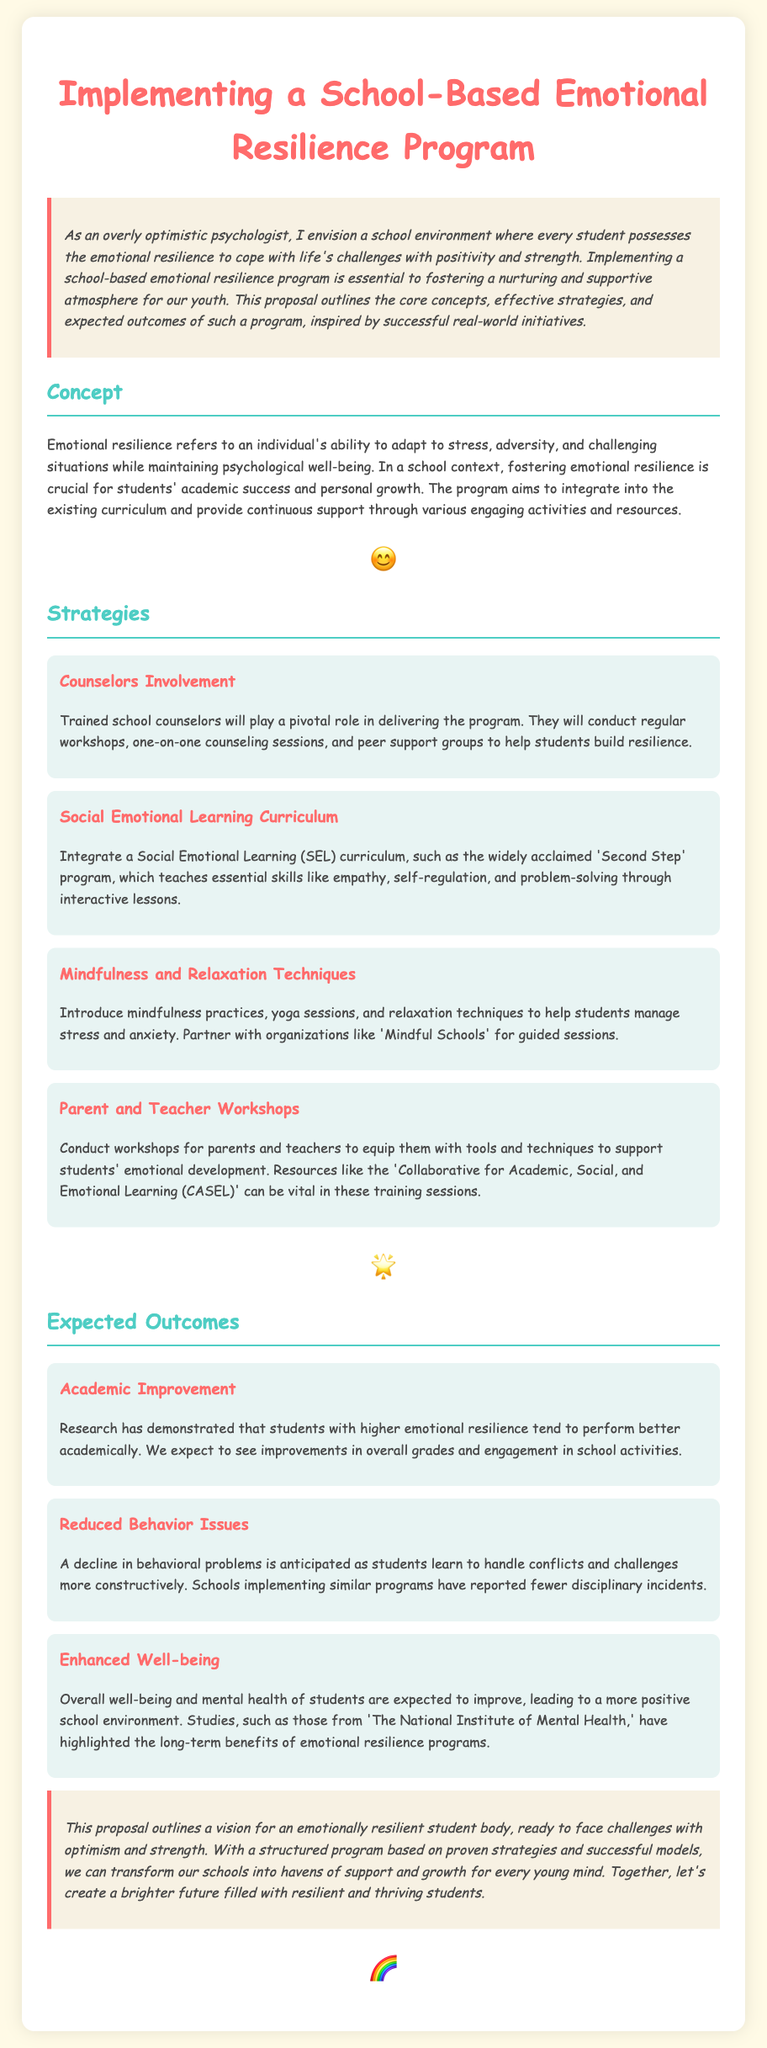What is the title of the proposal? The title of the proposal is prominently displayed at the top of the document.
Answer: Implementing a School-Based Emotional Resilience Program What is the main concept of the program? The main concept is summarized in the introductory paragraph, highlighting what the program aims to achieve.
Answer: Emotional resilience Who will conduct the regular workshops? This information is found in the Strategies section specifically about the role of counselors.
Answer: Trained school counselors Name one Social Emotional Learning curriculum mentioned. The curriculum mentioned is identified in the respective strategy.
Answer: Second Step What is one expected outcome of the program? The expected outcomes are discussed in a particular section, and one can be chosen from there.
Answer: Academic Improvement Which organization can assist with mindfulness sessions? The document specifically names an organization in the context of mindfulness practices.
Answer: Mindful Schools What is a suggested method to support parents and teachers? This suggestion appears in the related strategy for workshops.
Answer: Conduct workshops What is one of the benefits highlighted by studies on emotional resilience programs? This information is presented in the context of expected outcomes and studies mentioned.
Answer: Enhanced Well-being How many strategies are outlined in the proposal? The number of strategies can be counted from the strategies section of the document.
Answer: Four 